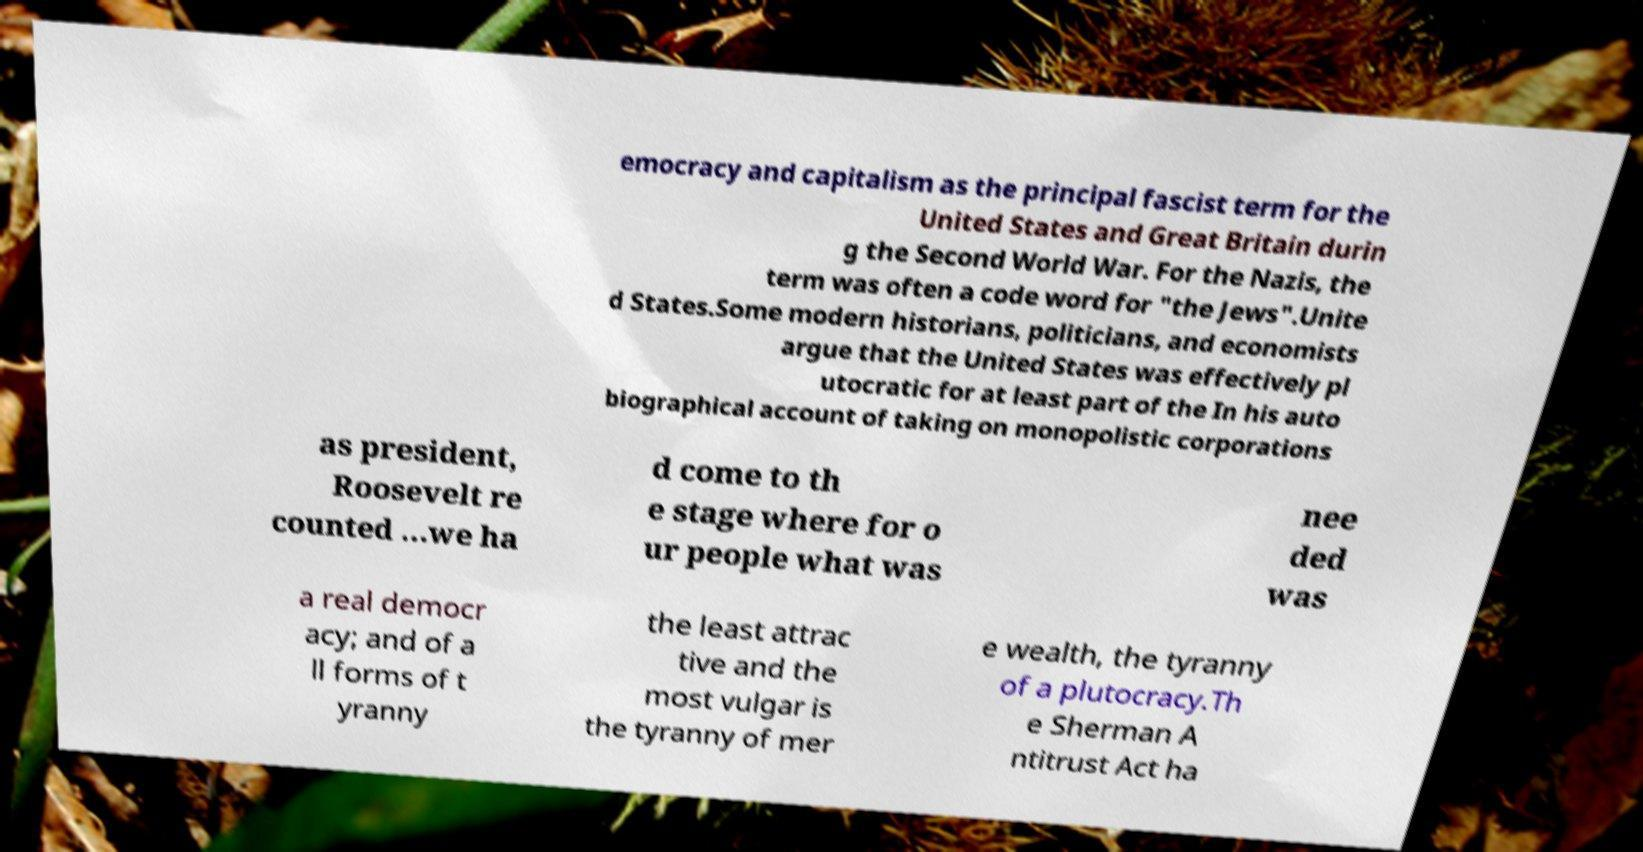Can you read and provide the text displayed in the image?This photo seems to have some interesting text. Can you extract and type it out for me? emocracy and capitalism as the principal fascist term for the United States and Great Britain durin g the Second World War. For the Nazis, the term was often a code word for "the Jews".Unite d States.Some modern historians, politicians, and economists argue that the United States was effectively pl utocratic for at least part of the In his auto biographical account of taking on monopolistic corporations as president, Roosevelt re counted …we ha d come to th e stage where for o ur people what was nee ded was a real democr acy; and of a ll forms of t yranny the least attrac tive and the most vulgar is the tyranny of mer e wealth, the tyranny of a plutocracy.Th e Sherman A ntitrust Act ha 